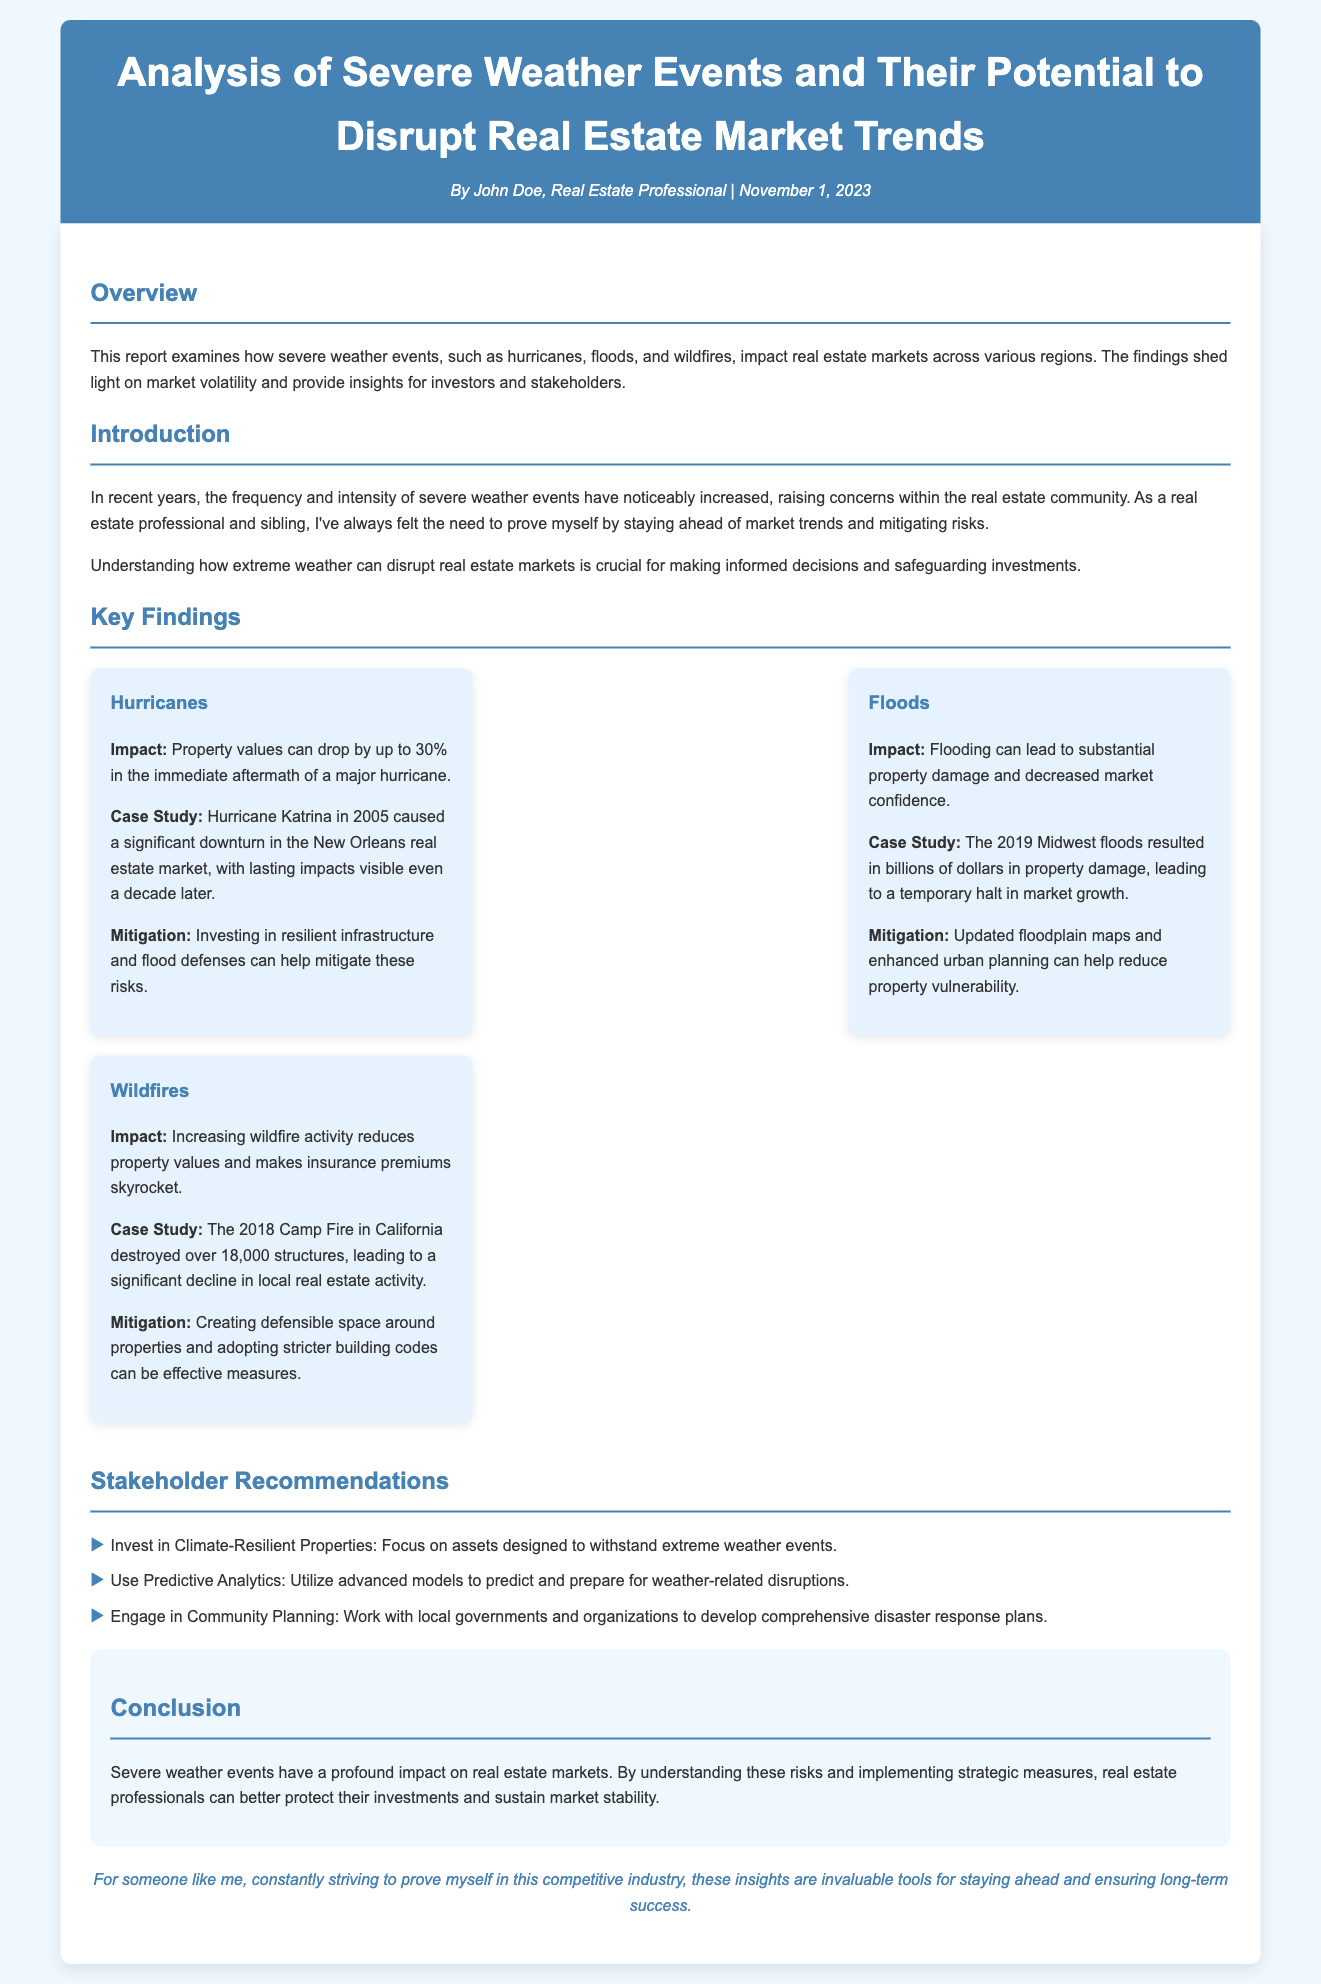What is the title of the report? The title of the report is displayed prominently at the top of the document.
Answer: Analysis of Severe Weather Events and Their Potential to Disrupt Real Estate Market Trends Who authored the report? The author's name is listed in the author-date section of the header.
Answer: John Doe What is the date of publication? The publication date is specified in the author-date section of the header.
Answer: November 1, 2023 What is the impact of hurricanes on property values? The report cites a specific figure regarding property value drops due to hurricanes.
Answer: 30% What was a significant hurricane case study mentioned? The document references a prominent hurricane to illustrate impacts on real estate.
Answer: Hurricane Katrina What did the 2019 Midwest floods result in? This is mentioned in the section discussing floods, specifically looking at outcomes.
Answer: Billions of dollars in property damage What is one recommendation for stakeholders? Recommendations for stakeholders are listed in bullet points within the document.
Answer: Invest in Climate-Resilient Properties What can help reduce property vulnerability to flooding? The document suggests measures for mitigating flood effects that can protect properties.
Answer: Updated floodplain maps What is a key finding regarding wildfires? A short description of the impact of wildfires on real estate is presented.
Answer: Reduces property values Why is understanding severe weather risks important for real estate professionals? The introduction highlights the necessity of this understanding for informed decision making.
Answer: Safeguarding investments 